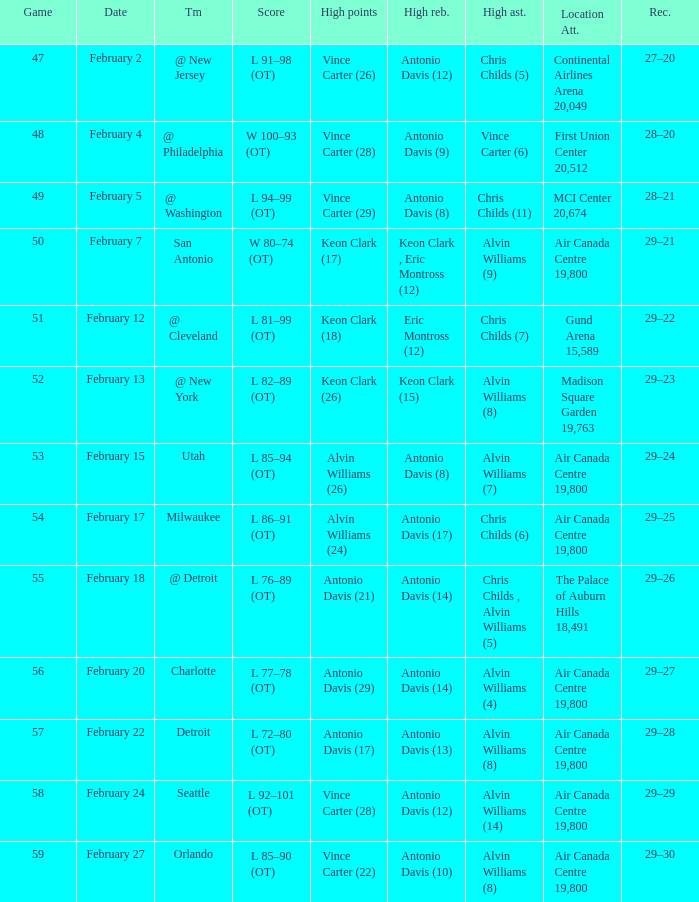What is the Team with a game of more than 56, and the score is l 85–90 (ot)? Orlando. 